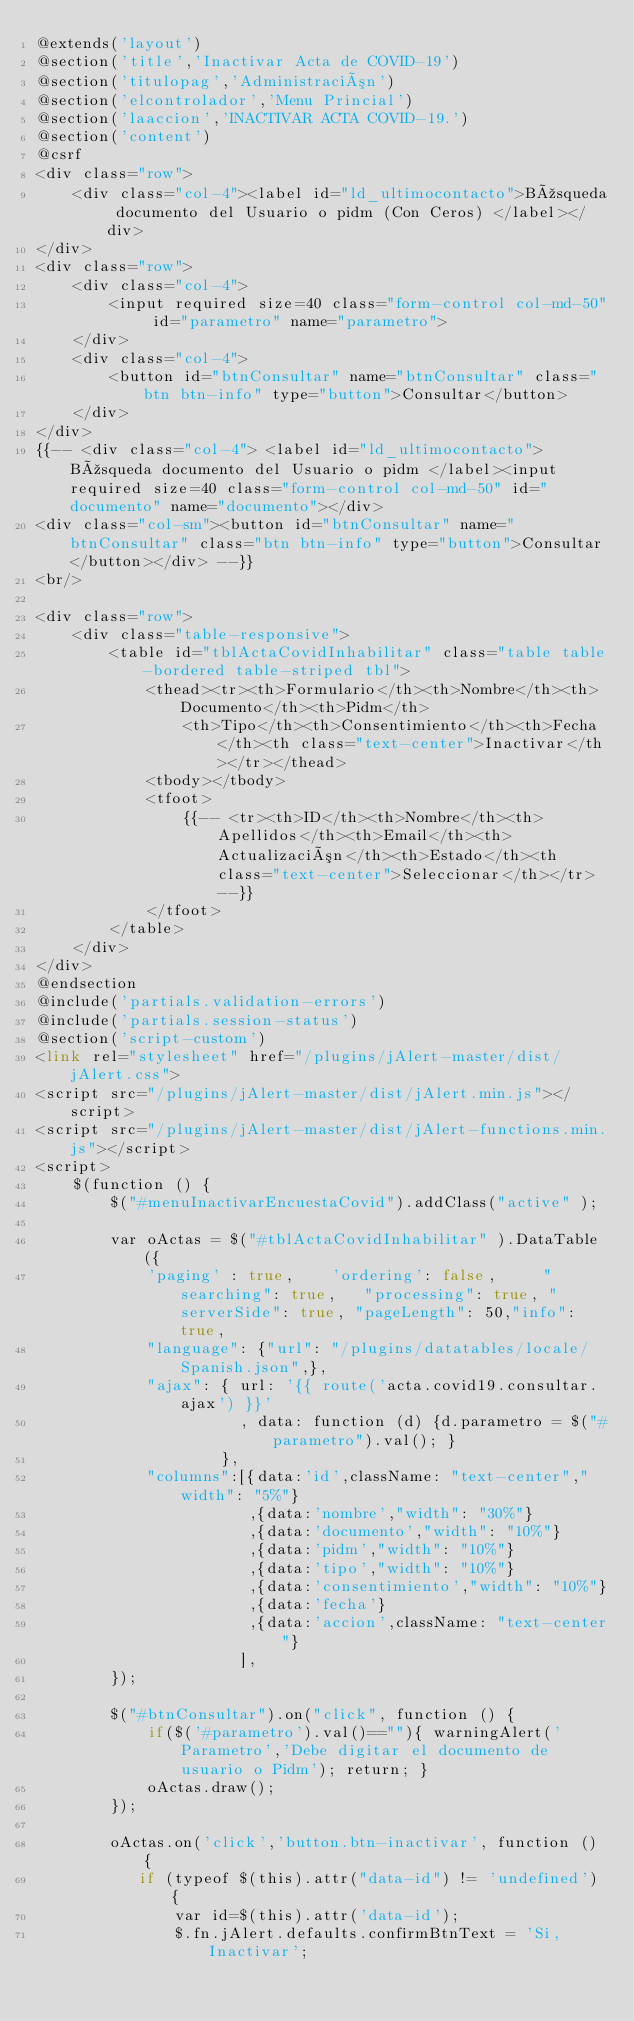Convert code to text. <code><loc_0><loc_0><loc_500><loc_500><_PHP_>@extends('layout')
@section('title','Inactivar Acta de COVID-19')
@section('titulopag','Administración')
@section('elcontrolador','Menu Princial')
@section('laaccion','INACTIVAR ACTA COVID-19.')
@section('content')
@csrf    
<div class="row">
    <div class="col-4"><label id="ld_ultimocontacto">Búsqueda documento del Usuario o pidm (Con Ceros) </label></div>    
</div>
<div class="row">
    <div class="col-4">
        <input required size=40 class="form-control col-md-50" id="parametro" name="parametro">
    </div>    
    <div class="col-4">        
        <button id="btnConsultar" name="btnConsultar" class="btn btn-info" type="button">Consultar</button>    
    </div>    
</div>    
{{-- <div class="col-4"> <label id="ld_ultimocontacto">Búsqueda documento del Usuario o pidm </label><input required size=40 class="form-control col-md-50" id="documento" name="documento"></div>
<div class="col-sm"><button id="btnConsultar" name="btnConsultar" class="btn btn-info" type="button">Consultar</button></div> --}}
<br/>

<div class="row">    
    <div class="table-responsive">
        <table id="tblActaCovidInhabilitar" class="table table-bordered table-striped tbl">
            <thead><tr><th>Formulario</th><th>Nombre</th><th>Documento</th><th>Pidm</th>
                <th>Tipo</th><th>Consentimiento</th><th>Fecha</th><th class="text-center">Inactivar</th></tr></thead>
            <tbody></tbody>
            <tfoot>
                {{-- <tr><th>ID</th><th>Nombre</th><th>Apellidos</th><th>Email</th><th>Actualización</th><th>Estado</th><th class="text-center">Seleccionar</th></tr> --}}
            </tfoot>
        </table>
    </div>    
</div>
@endsection
@include('partials.validation-errors')
@include('partials.session-status')
@section('script-custom')
<link rel="stylesheet" href="/plugins/jAlert-master/dist/jAlert.css">
<script src="/plugins/jAlert-master/dist/jAlert.min.js"></script>
<script src="/plugins/jAlert-master/dist/jAlert-functions.min.js"></script>
<script>         
    $(function () {
        $("#menuInactivarEncuestaCovid").addClass("active" );

        var oActas = $("#tblActaCovidInhabilitar" ).DataTable({
            'paging' : true,    'ordering': false,     "searching": true,   "processing": true, "serverSide": true, "pageLength": 50,"info": true,
            "language": {"url": "/plugins/datatables/locale/Spanish.json",},
            "ajax": { url: '{{ route('acta.covid19.consultar.ajax') }}'
                      , data: function (d) {d.parametro = $("#parametro").val(); }                      
                    },
            "columns":[{data:'id',className: "text-center","width": "5%"}                       
                       ,{data:'nombre',"width": "30%"}
                       ,{data:'documento',"width": "10%"}
                       ,{data:'pidm',"width": "10%"}
                       ,{data:'tipo',"width": "10%"}
                       ,{data:'consentimiento',"width": "10%"}
                       ,{data:'fecha'}
                       ,{data:'accion',className: "text-center"}
                      ],            
        });

        $("#btnConsultar").on("click", function () {                                    
            if($('#parametro').val()==""){ warningAlert('Parametro','Debe digitar el documento de usuario o Pidm'); return; }
            oActas.draw();            
        });

        oActas.on('click','button.btn-inactivar', function () {
           if (typeof $(this).attr("data-id") != 'undefined') {
               var id=$(this).attr('data-id');
               $.fn.jAlert.defaults.confirmBtnText = 'Si, Inactivar';</code> 